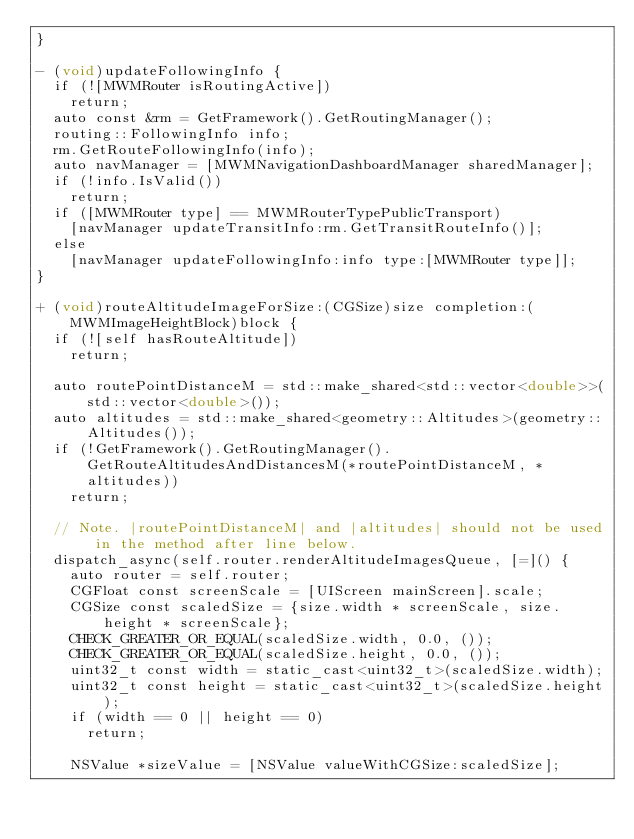<code> <loc_0><loc_0><loc_500><loc_500><_ObjectiveC_>}

- (void)updateFollowingInfo {
  if (![MWMRouter isRoutingActive])
    return;
  auto const &rm = GetFramework().GetRoutingManager();
  routing::FollowingInfo info;
  rm.GetRouteFollowingInfo(info);
  auto navManager = [MWMNavigationDashboardManager sharedManager];
  if (!info.IsValid())
    return;
  if ([MWMRouter type] == MWMRouterTypePublicTransport)
    [navManager updateTransitInfo:rm.GetTransitRouteInfo()];
  else
    [navManager updateFollowingInfo:info type:[MWMRouter type]];
}

+ (void)routeAltitudeImageForSize:(CGSize)size completion:(MWMImageHeightBlock)block {
  if (![self hasRouteAltitude])
    return;

  auto routePointDistanceM = std::make_shared<std::vector<double>>(std::vector<double>());
  auto altitudes = std::make_shared<geometry::Altitudes>(geometry::Altitudes());
  if (!GetFramework().GetRoutingManager().GetRouteAltitudesAndDistancesM(*routePointDistanceM, *altitudes))
    return;

  // Note. |routePointDistanceM| and |altitudes| should not be used in the method after line below.
  dispatch_async(self.router.renderAltitudeImagesQueue, [=]() {
    auto router = self.router;
    CGFloat const screenScale = [UIScreen mainScreen].scale;
    CGSize const scaledSize = {size.width * screenScale, size.height * screenScale};
    CHECK_GREATER_OR_EQUAL(scaledSize.width, 0.0, ());
    CHECK_GREATER_OR_EQUAL(scaledSize.height, 0.0, ());
    uint32_t const width = static_cast<uint32_t>(scaledSize.width);
    uint32_t const height = static_cast<uint32_t>(scaledSize.height);
    if (width == 0 || height == 0)
      return;

    NSValue *sizeValue = [NSValue valueWithCGSize:scaledSize];</code> 